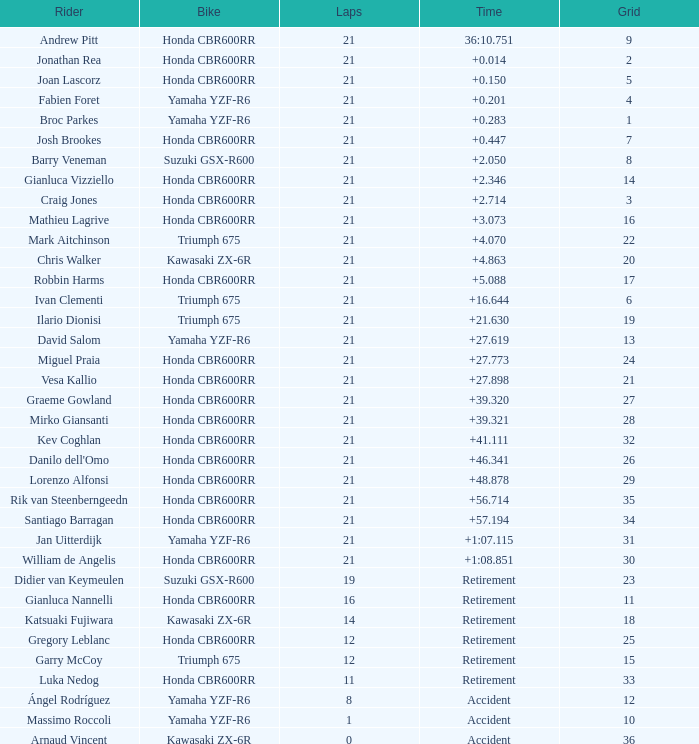Who is the competitor with under 16 laps, a grid ranking of 10, operating a yamaha yzf-r6, and terminating with an accident? Massimo Roccoli. 